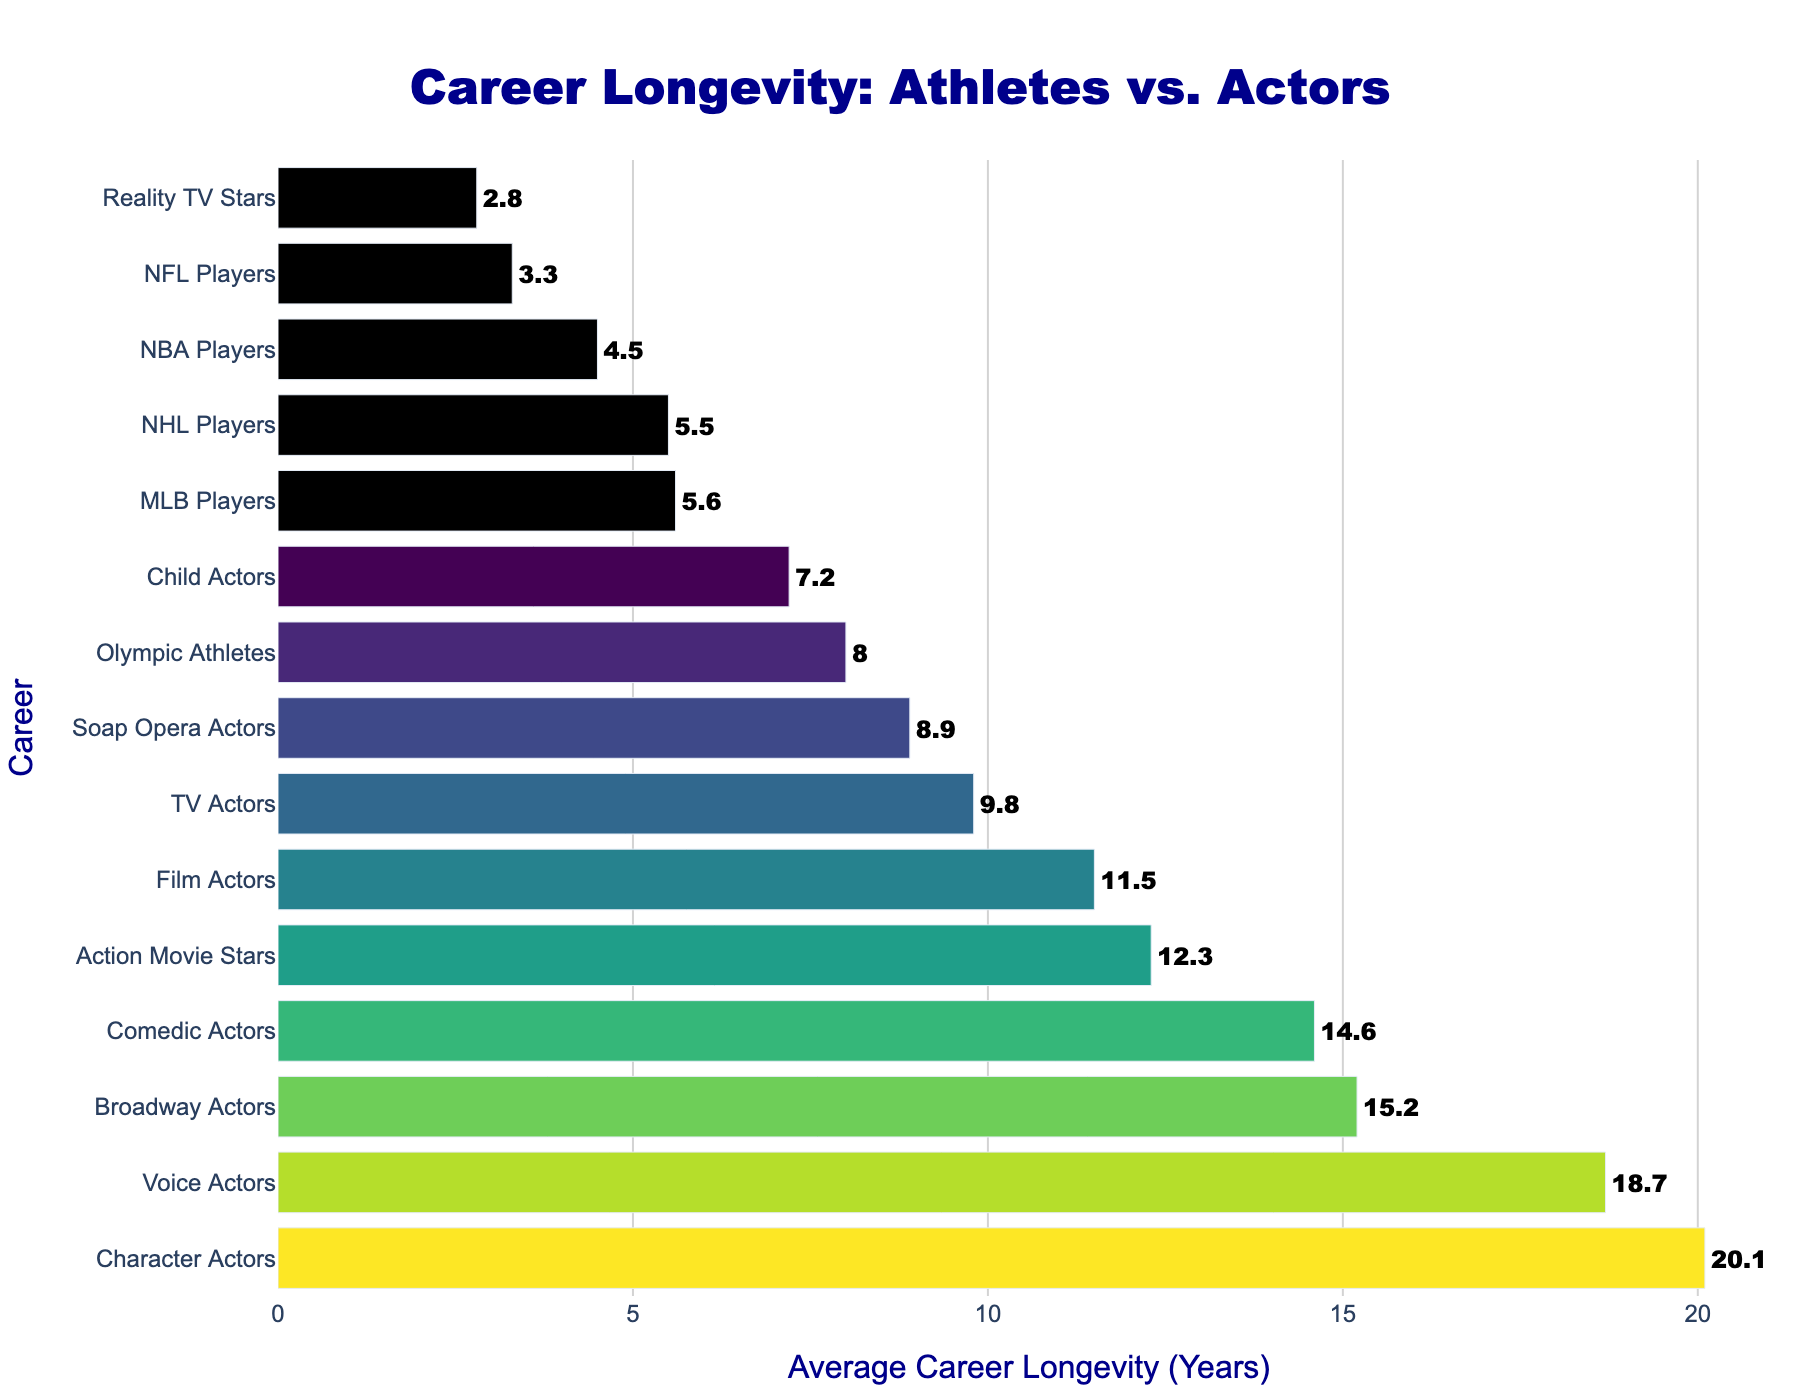What's the career with the longest average longevity? To find the career with the longest average longevity, look at the highest bar. The label on the y-axis corresponding to this bar represents the career with the longest average longevity.
Answer: Character Actors Which has a longer average career longevity, Film Actors or Olympic Athletes? Compare the lengths of the bars corresponding to Film Actors and Olympic Athletes. The longer bar represents the career with the longer average longevity.
Answer: Film Actors By how many years do TV Actors outlast NFL Players on average? Find the heights of the bars corresponding to TV Actors and NFL Players and subtract the NFL Players' average longevity from that of TV Actors.
Answer: 6.5 years What is the average career longevity of Action Movie Stars and Soap Opera Actors combined? Sum the values of the average career longevity for Action Movie Stars and Soap Opera Actors and then divide by 2.
Answer: 10.6 years Are there more professional athletes or actors shown in the plot? Count the number of careers listed under each category (athletes or actors) using the y-axis labels.
Answer: Actors Which actor type has the shortest career longevity, and what is it? Identify the actor type with the shortest bar among actors and note the corresponding average career longevity.
Answer: Child Actors, 7.2 years How much longer, on average, do Broadway Actors work compared to Reality TV Stars? Subtract the average career longevity of Reality TV Stars from that of Broadway Actors.
Answer: 12.4 years Which career has a more similar average longevity to NHL Players: TV Actors or MLB Players? Compare the average longevity of NHL Players to both TV Actors and MLB Players and see which is closer in value.
Answer: MLB Players Which category shows a wider range of career longevity, actors or athletes? Identify the minimum and maximum career longevity within each category, then calculate the range (difference between the maximum and minimum values) for each.
Answer: Actors Do comedic actors typically have a career longer than Olympic Athletes? Compare the heights of the bars for Comedic Actors and Olympic Athletes. The longer bar indicates the career with a longer average longevity.
Answer: Yes 